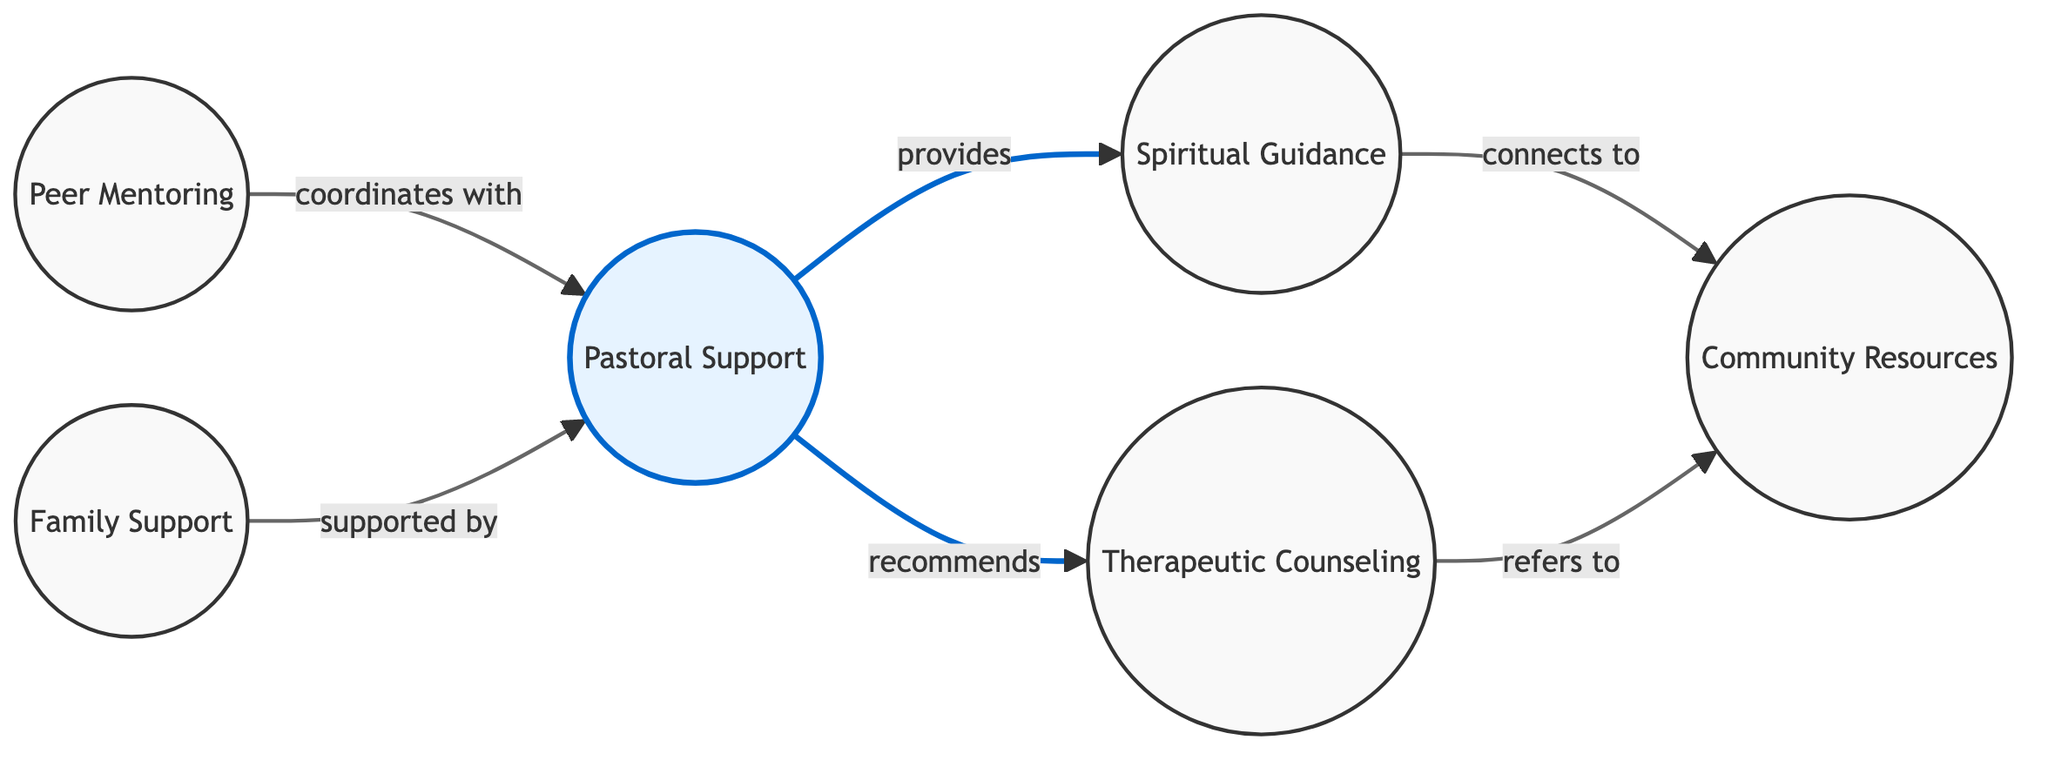What are the main support systems for officers facing life challenges? The diagram lists six support systems, which are: Pastoral Support, Peer Mentoring, Family Support, Therapeutic Counseling, Spiritual Guidance, and Community Resources.
Answer: Pastoral Support, Peer Mentoring, Family Support, Therapeutic Counseling, Spiritual Guidance, Community Resources How many nodes are in the diagram? The diagram contains six nodes: Pastoral Support, Peer Mentoring, Family Support, Therapeutic Counseling, Spiritual Guidance, and Community Resources.
Answer: 6 What kind of support does Pastoral Support provide to Spiritual Guidance? The diagram indicates that Pastoral Support "provides" Spiritual Guidance, establishing a direct supportive relationship from Pastoral Support to Spiritual Guidance.
Answer: provides Which node is supported by Family Support? The diagram shows that Family Support is "supported by" Pastoral Support, establishing that Pastoral Support is the node providing support to Family Support.
Answer: Pastoral Support Which two nodes coordinate with each other? According to the diagram, Peer Mentoring "coordinates with" Pastoral Support, indicating a collaborative relationship between these two nodes.
Answer: Peer Mentoring and Pastoral Support What resources does Therapeutic Counseling refer to? The diagram states that Therapeutic Counseling "refers to" Community Resources, meaning it directs patients to this support system for additional assistance.
Answer: Community Resources What connection exists between Spiritual Guidance and Community Resources? Spiritual Guidance "connects to" Community Resources, suggesting a pathway that allows Spiritual Guidance to link officers to broader community support.
Answer: connects to Which node has two outgoing connections? Pastoral Support has two outgoing connections: it "provides" Spiritual Guidance and "recommends" Therapeutic Counseling, showing its role as a central support system.
Answer: Pastoral Support How many edges are in the diagram? The diagram consists of six edges, each representing a relationship between two nodes, connecting various support systems for officers.
Answer: 6 